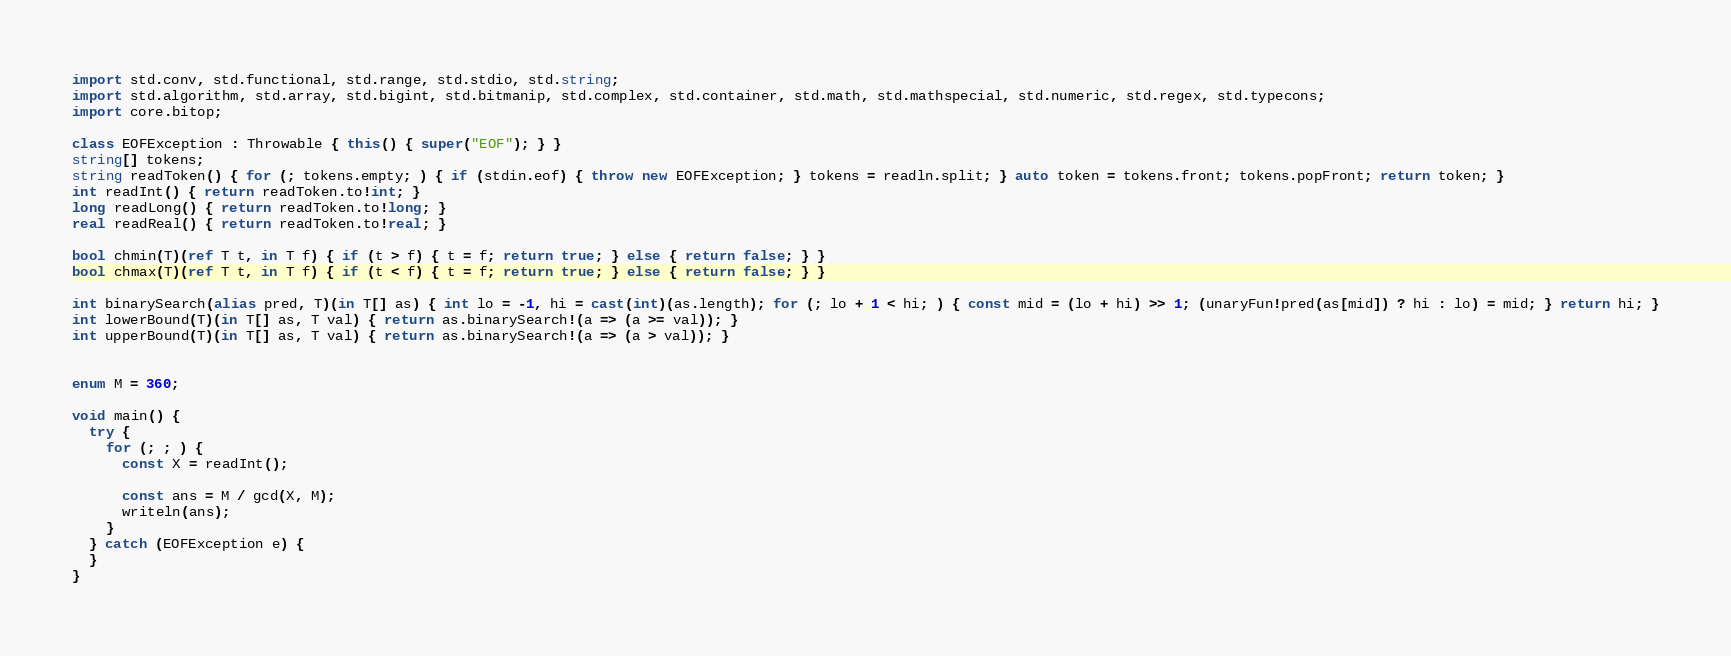<code> <loc_0><loc_0><loc_500><loc_500><_D_>import std.conv, std.functional, std.range, std.stdio, std.string;
import std.algorithm, std.array, std.bigint, std.bitmanip, std.complex, std.container, std.math, std.mathspecial, std.numeric, std.regex, std.typecons;
import core.bitop;

class EOFException : Throwable { this() { super("EOF"); } }
string[] tokens;
string readToken() { for (; tokens.empty; ) { if (stdin.eof) { throw new EOFException; } tokens = readln.split; } auto token = tokens.front; tokens.popFront; return token; }
int readInt() { return readToken.to!int; }
long readLong() { return readToken.to!long; }
real readReal() { return readToken.to!real; }

bool chmin(T)(ref T t, in T f) { if (t > f) { t = f; return true; } else { return false; } }
bool chmax(T)(ref T t, in T f) { if (t < f) { t = f; return true; } else { return false; } }

int binarySearch(alias pred, T)(in T[] as) { int lo = -1, hi = cast(int)(as.length); for (; lo + 1 < hi; ) { const mid = (lo + hi) >> 1; (unaryFun!pred(as[mid]) ? hi : lo) = mid; } return hi; }
int lowerBound(T)(in T[] as, T val) { return as.binarySearch!(a => (a >= val)); }
int upperBound(T)(in T[] as, T val) { return as.binarySearch!(a => (a > val)); }


enum M = 360;

void main() {
  try {
    for (; ; ) {
      const X = readInt();
      
      const ans = M / gcd(X, M);
      writeln(ans);
    }
  } catch (EOFException e) {
  }
}
</code> 